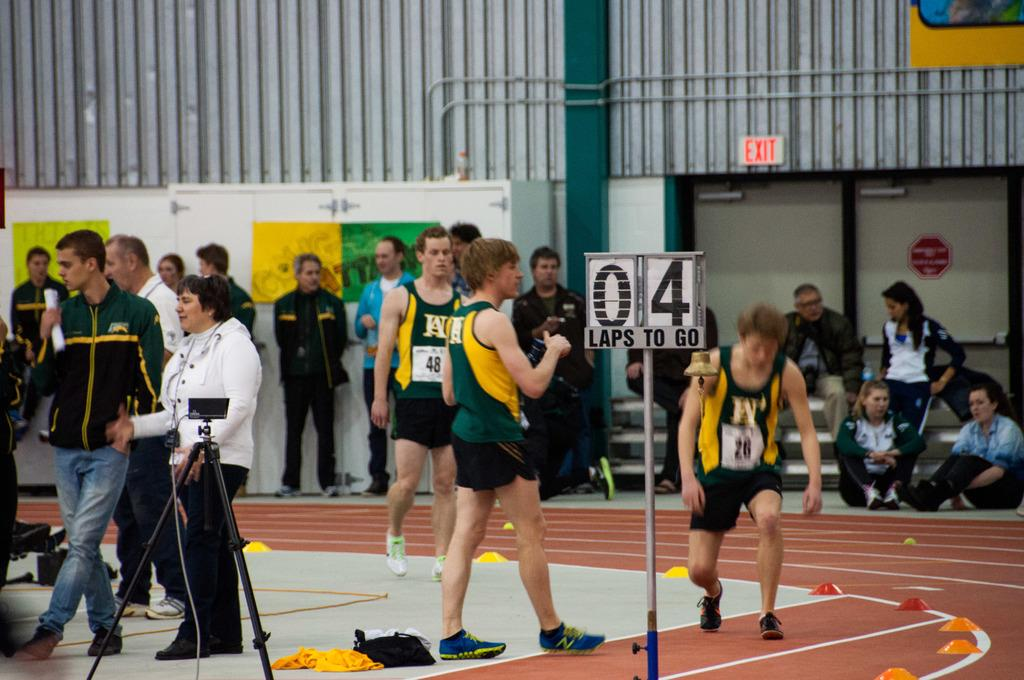<image>
Provide a brief description of the given image. A track team  running an inside track with 0 